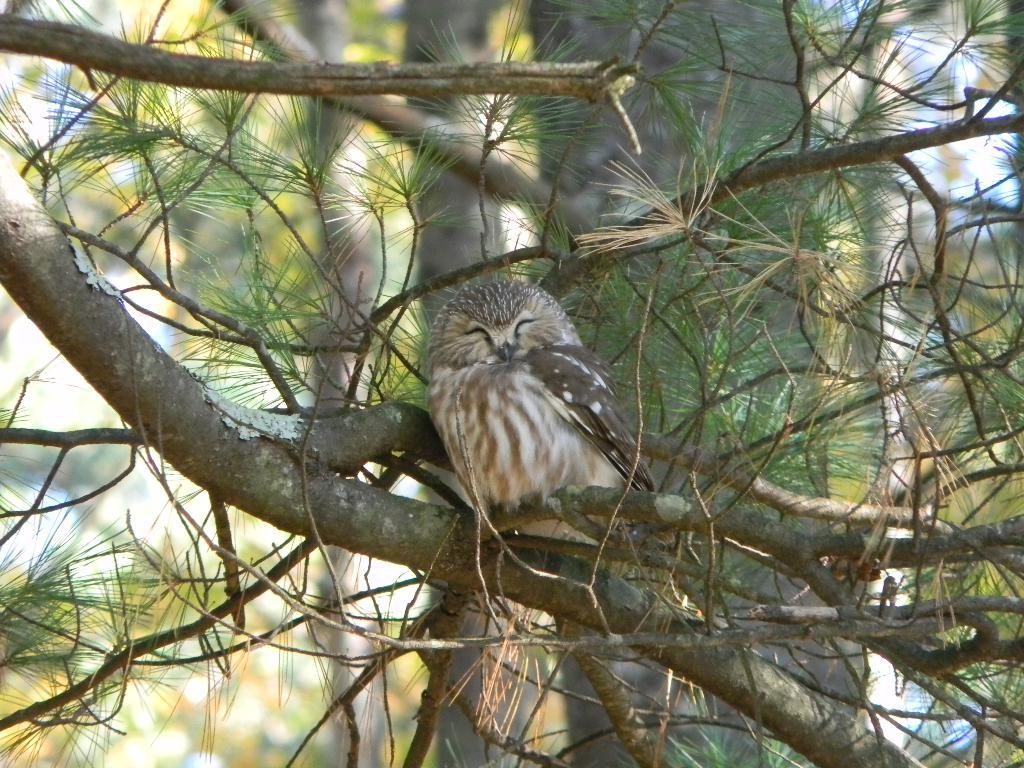What type of animal can be seen in the image? There is a bird in the image. Where is the bird located? The bird is on a tree. Can you describe the bird's appearance? The bird resembles an owl. What can be seen in the background of the image? There are trees in the background of the image. How does the bird's aunt feel about the board in the image? There is no board, aunt, or any indication of feelings present in the image. The image only features a bird on a tree and trees in the background. 